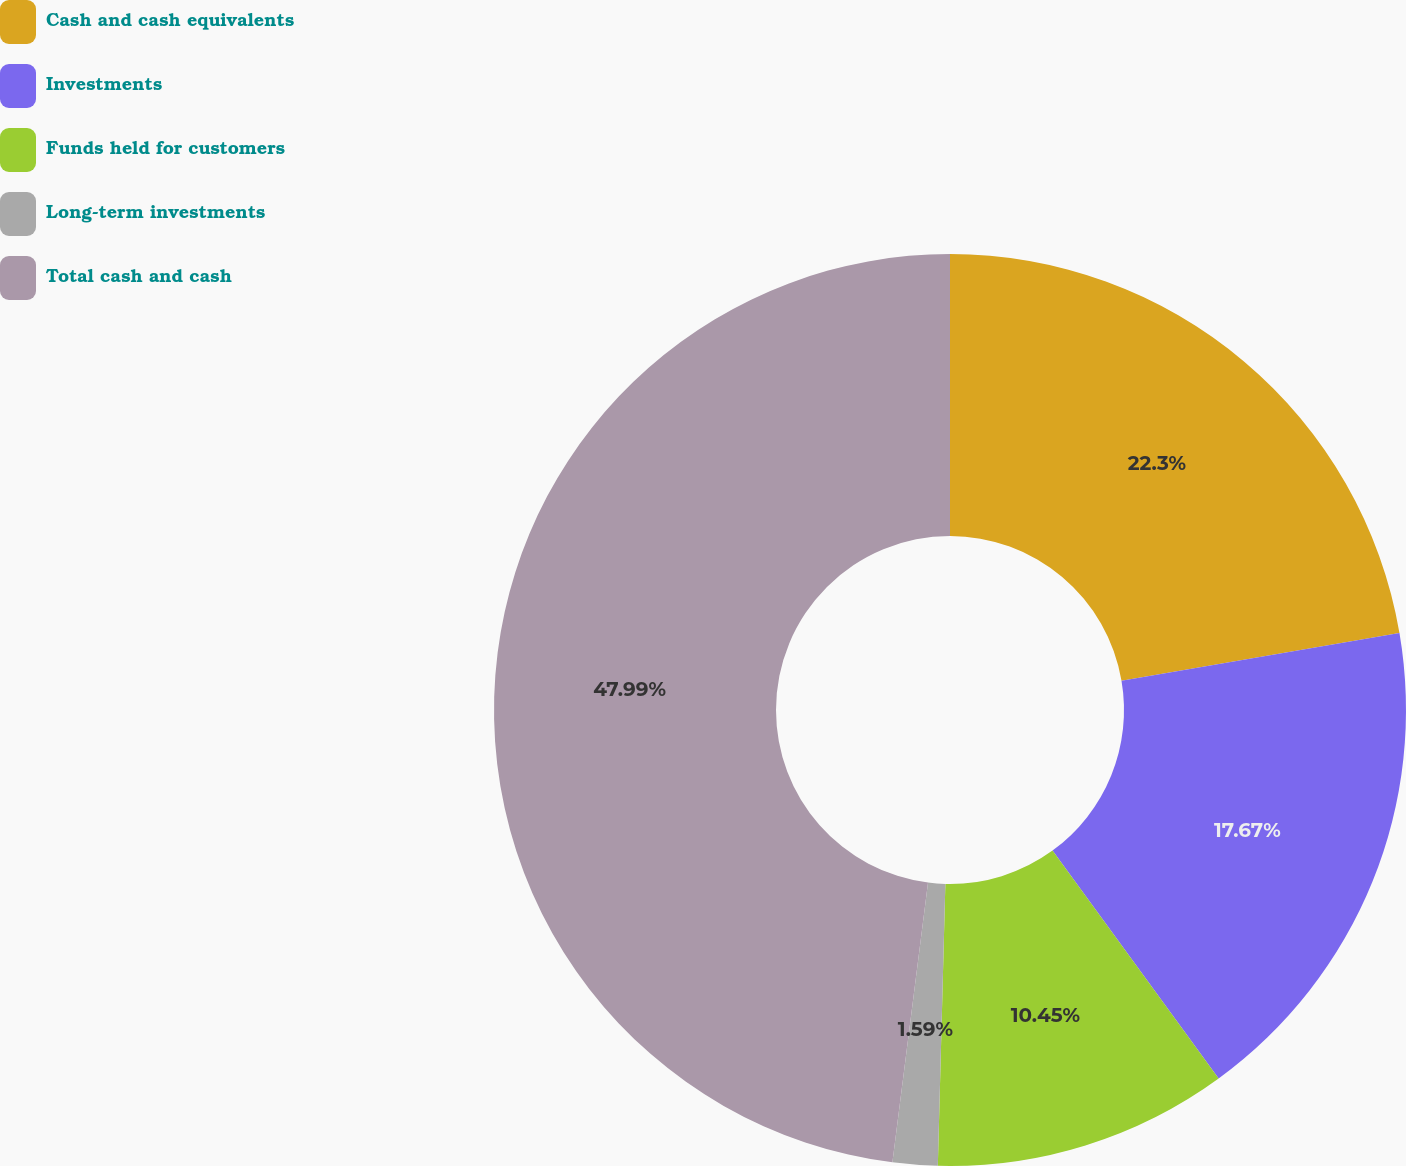<chart> <loc_0><loc_0><loc_500><loc_500><pie_chart><fcel>Cash and cash equivalents<fcel>Investments<fcel>Funds held for customers<fcel>Long-term investments<fcel>Total cash and cash<nl><fcel>22.3%<fcel>17.67%<fcel>10.45%<fcel>1.59%<fcel>47.98%<nl></chart> 